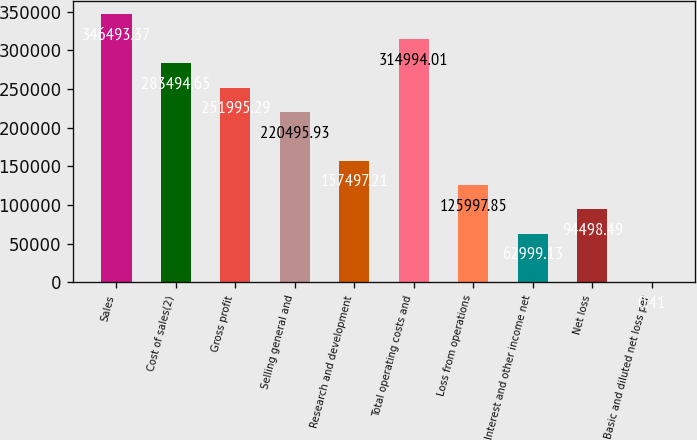Convert chart. <chart><loc_0><loc_0><loc_500><loc_500><bar_chart><fcel>Sales<fcel>Cost of sales(2)<fcel>Gross profit<fcel>Selling general and<fcel>Research and development<fcel>Total operating costs and<fcel>Loss from operations<fcel>Interest and other income net<fcel>Net loss<fcel>Basic and diluted net loss per<nl><fcel>346493<fcel>283495<fcel>251995<fcel>220496<fcel>157497<fcel>314994<fcel>125998<fcel>62999.1<fcel>94498.5<fcel>0.41<nl></chart> 